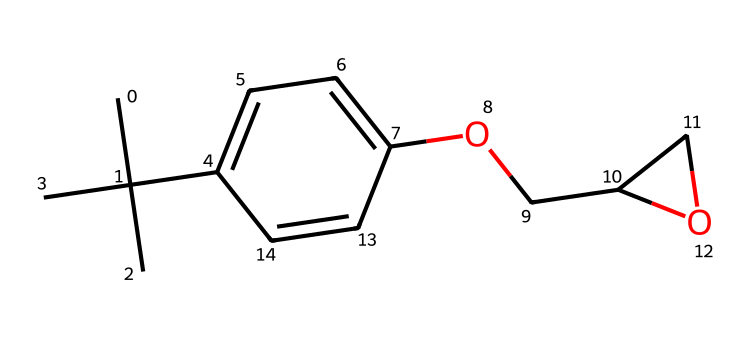What is the functional group present in this structure? The structure contains a -O- group (ether) connecting two parts of the molecule (the aromatic ring and the cyclic structure), indicating the presence of an ether functional group.
Answer: ether How many carbon atoms are in the chemical structure? By counting the carbon atoms represented in the SMILES notation, we find a total of 12 carbon atoms present, including those in the side chains and those making up the cyclic portion.
Answer: 12 What type of aromatic ring does this molecule contain? The molecule features a phenolic structure, indicated by the presence of the benzene ring with an -OH group attached, making it a derivative of phenol.
Answer: phenolic How many rings are present in this chemical structure? The analysis of the SMILES shows one aromatic ring and one cyclic structure (the oxirane), resulting in a total of two rings present in this molecule.
Answer: 2 What hazardous properties can be associated with epoxy resins? Epoxy resins are known to be skin irritants and sensitizers, providing risks like allergic reactions upon exposure, which can be derived from their chemical reactivity and structure.
Answer: skin irritants What does the presence of an ether linkage imply about the reactivity of this molecule? The ether linkage can decrease the overall reactivity of the molecule, making it more stable than other functional groups like aldehydes or ketones, which are more reactive due to their carbonyl groups.
Answer: stable 